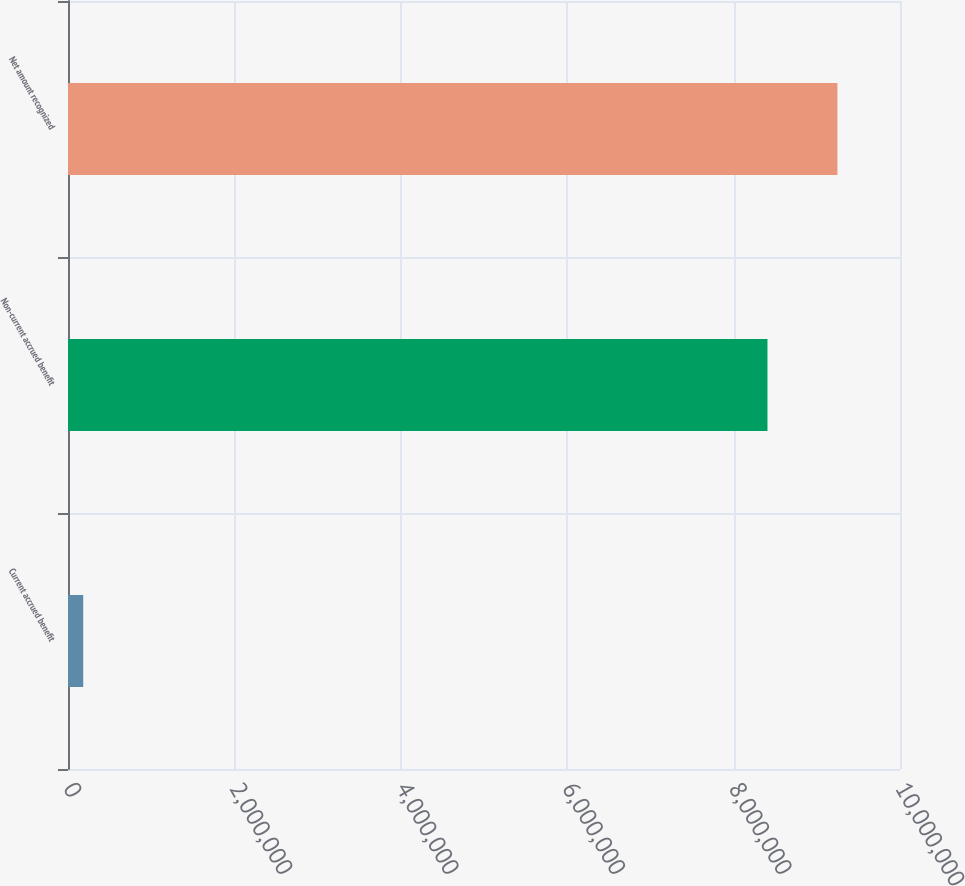Convert chart to OTSL. <chart><loc_0><loc_0><loc_500><loc_500><bar_chart><fcel>Current accrued benefit<fcel>Non-current accrued benefit<fcel>Net amount recognized<nl><fcel>183000<fcel>8.407e+06<fcel>9.2477e+06<nl></chart> 